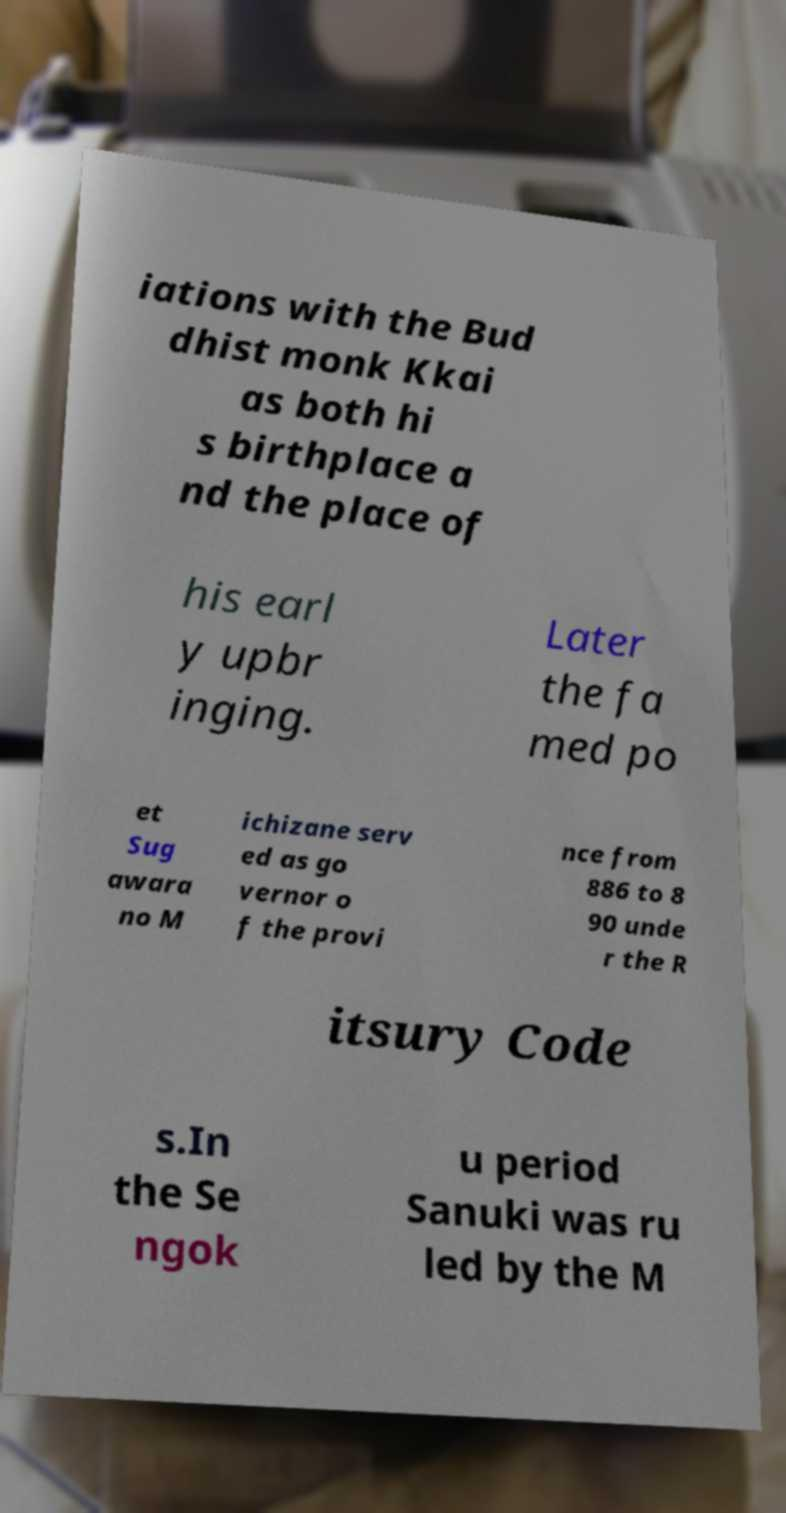I need the written content from this picture converted into text. Can you do that? iations with the Bud dhist monk Kkai as both hi s birthplace a nd the place of his earl y upbr inging. Later the fa med po et Sug awara no M ichizane serv ed as go vernor o f the provi nce from 886 to 8 90 unde r the R itsury Code s.In the Se ngok u period Sanuki was ru led by the M 